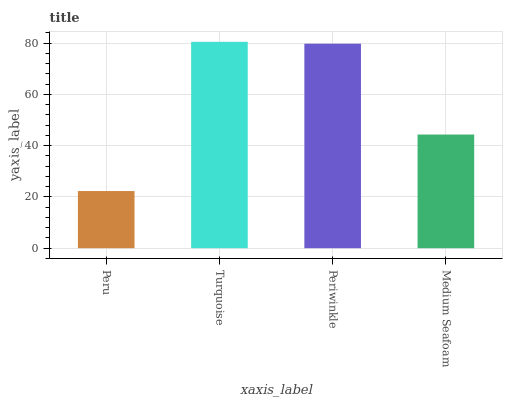Is Peru the minimum?
Answer yes or no. Yes. Is Turquoise the maximum?
Answer yes or no. Yes. Is Periwinkle the minimum?
Answer yes or no. No. Is Periwinkle the maximum?
Answer yes or no. No. Is Turquoise greater than Periwinkle?
Answer yes or no. Yes. Is Periwinkle less than Turquoise?
Answer yes or no. Yes. Is Periwinkle greater than Turquoise?
Answer yes or no. No. Is Turquoise less than Periwinkle?
Answer yes or no. No. Is Periwinkle the high median?
Answer yes or no. Yes. Is Medium Seafoam the low median?
Answer yes or no. Yes. Is Medium Seafoam the high median?
Answer yes or no. No. Is Periwinkle the low median?
Answer yes or no. No. 